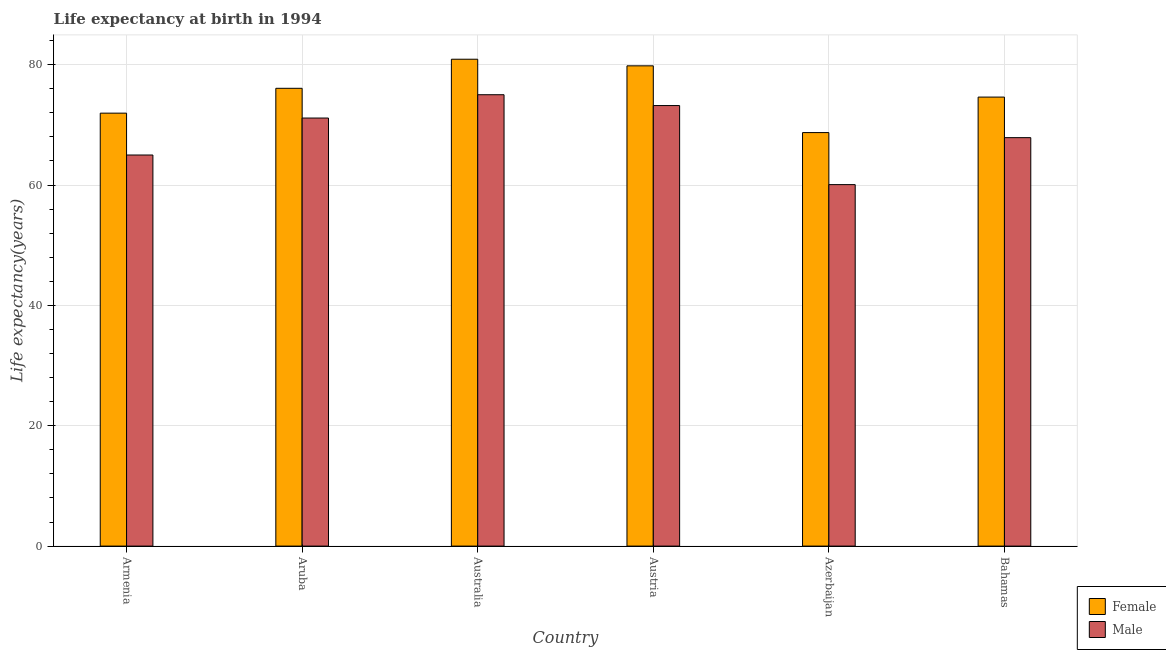How many different coloured bars are there?
Make the answer very short. 2. How many groups of bars are there?
Give a very brief answer. 6. How many bars are there on the 1st tick from the left?
Give a very brief answer. 2. How many bars are there on the 2nd tick from the right?
Offer a very short reply. 2. What is the label of the 1st group of bars from the left?
Your answer should be compact. Armenia. In how many cases, is the number of bars for a given country not equal to the number of legend labels?
Give a very brief answer. 0. What is the life expectancy(female) in Bahamas?
Offer a very short reply. 74.61. Across all countries, what is the maximum life expectancy(female)?
Your answer should be very brief. 80.9. Across all countries, what is the minimum life expectancy(female)?
Make the answer very short. 68.71. In which country was the life expectancy(female) minimum?
Provide a short and direct response. Azerbaijan. What is the total life expectancy(male) in the graph?
Make the answer very short. 412.24. What is the difference between the life expectancy(female) in Armenia and that in Australia?
Make the answer very short. -8.96. What is the difference between the life expectancy(female) in Azerbaijan and the life expectancy(male) in Armenia?
Make the answer very short. 3.73. What is the average life expectancy(male) per country?
Keep it short and to the point. 68.71. What is the difference between the life expectancy(female) and life expectancy(male) in Aruba?
Your response must be concise. 4.94. In how many countries, is the life expectancy(male) greater than 48 years?
Ensure brevity in your answer.  6. What is the ratio of the life expectancy(male) in Australia to that in Austria?
Ensure brevity in your answer.  1.02. Is the difference between the life expectancy(male) in Aruba and Austria greater than the difference between the life expectancy(female) in Aruba and Austria?
Provide a short and direct response. Yes. What is the difference between the highest and the second highest life expectancy(female)?
Your answer should be compact. 1.1. What is the difference between the highest and the lowest life expectancy(female)?
Your response must be concise. 12.19. In how many countries, is the life expectancy(male) greater than the average life expectancy(male) taken over all countries?
Ensure brevity in your answer.  3. How many bars are there?
Offer a terse response. 12. Are all the bars in the graph horizontal?
Your answer should be compact. No. How many countries are there in the graph?
Your answer should be very brief. 6. What is the difference between two consecutive major ticks on the Y-axis?
Offer a terse response. 20. Are the values on the major ticks of Y-axis written in scientific E-notation?
Give a very brief answer. No. Does the graph contain any zero values?
Provide a short and direct response. No. Does the graph contain grids?
Make the answer very short. Yes. What is the title of the graph?
Ensure brevity in your answer.  Life expectancy at birth in 1994. What is the label or title of the X-axis?
Your answer should be compact. Country. What is the label or title of the Y-axis?
Provide a succinct answer. Life expectancy(years). What is the Life expectancy(years) in Female in Armenia?
Your response must be concise. 71.94. What is the Life expectancy(years) in Male in Armenia?
Keep it short and to the point. 64.98. What is the Life expectancy(years) in Female in Aruba?
Offer a very short reply. 76.07. What is the Life expectancy(years) of Male in Aruba?
Your answer should be very brief. 71.13. What is the Life expectancy(years) of Female in Australia?
Ensure brevity in your answer.  80.9. What is the Life expectancy(years) of Female in Austria?
Offer a very short reply. 79.8. What is the Life expectancy(years) of Male in Austria?
Give a very brief answer. 73.2. What is the Life expectancy(years) in Female in Azerbaijan?
Provide a short and direct response. 68.71. What is the Life expectancy(years) in Male in Azerbaijan?
Give a very brief answer. 60.06. What is the Life expectancy(years) of Female in Bahamas?
Give a very brief answer. 74.61. What is the Life expectancy(years) in Male in Bahamas?
Ensure brevity in your answer.  67.87. Across all countries, what is the maximum Life expectancy(years) in Female?
Provide a short and direct response. 80.9. Across all countries, what is the maximum Life expectancy(years) of Male?
Provide a short and direct response. 75. Across all countries, what is the minimum Life expectancy(years) in Female?
Offer a terse response. 68.71. Across all countries, what is the minimum Life expectancy(years) of Male?
Your response must be concise. 60.06. What is the total Life expectancy(years) in Female in the graph?
Make the answer very short. 452.02. What is the total Life expectancy(years) of Male in the graph?
Keep it short and to the point. 412.24. What is the difference between the Life expectancy(years) of Female in Armenia and that in Aruba?
Provide a succinct answer. -4.13. What is the difference between the Life expectancy(years) of Male in Armenia and that in Aruba?
Offer a terse response. -6.14. What is the difference between the Life expectancy(years) of Female in Armenia and that in Australia?
Offer a terse response. -8.96. What is the difference between the Life expectancy(years) of Male in Armenia and that in Australia?
Your answer should be compact. -10.02. What is the difference between the Life expectancy(years) in Female in Armenia and that in Austria?
Provide a short and direct response. -7.86. What is the difference between the Life expectancy(years) of Male in Armenia and that in Austria?
Offer a terse response. -8.22. What is the difference between the Life expectancy(years) in Female in Armenia and that in Azerbaijan?
Your answer should be very brief. 3.23. What is the difference between the Life expectancy(years) in Male in Armenia and that in Azerbaijan?
Ensure brevity in your answer.  4.92. What is the difference between the Life expectancy(years) of Female in Armenia and that in Bahamas?
Make the answer very short. -2.67. What is the difference between the Life expectancy(years) in Male in Armenia and that in Bahamas?
Keep it short and to the point. -2.88. What is the difference between the Life expectancy(years) of Female in Aruba and that in Australia?
Give a very brief answer. -4.83. What is the difference between the Life expectancy(years) in Male in Aruba and that in Australia?
Your response must be concise. -3.87. What is the difference between the Life expectancy(years) in Female in Aruba and that in Austria?
Offer a very short reply. -3.73. What is the difference between the Life expectancy(years) of Male in Aruba and that in Austria?
Ensure brevity in your answer.  -2.07. What is the difference between the Life expectancy(years) in Female in Aruba and that in Azerbaijan?
Make the answer very short. 7.36. What is the difference between the Life expectancy(years) of Male in Aruba and that in Azerbaijan?
Keep it short and to the point. 11.06. What is the difference between the Life expectancy(years) in Female in Aruba and that in Bahamas?
Provide a short and direct response. 1.46. What is the difference between the Life expectancy(years) of Male in Aruba and that in Bahamas?
Provide a succinct answer. 3.26. What is the difference between the Life expectancy(years) of Female in Australia and that in Austria?
Provide a short and direct response. 1.1. What is the difference between the Life expectancy(years) in Male in Australia and that in Austria?
Your response must be concise. 1.8. What is the difference between the Life expectancy(years) in Female in Australia and that in Azerbaijan?
Offer a terse response. 12.19. What is the difference between the Life expectancy(years) of Male in Australia and that in Azerbaijan?
Offer a terse response. 14.94. What is the difference between the Life expectancy(years) of Female in Australia and that in Bahamas?
Give a very brief answer. 6.29. What is the difference between the Life expectancy(years) of Male in Australia and that in Bahamas?
Keep it short and to the point. 7.13. What is the difference between the Life expectancy(years) of Female in Austria and that in Azerbaijan?
Give a very brief answer. 11.09. What is the difference between the Life expectancy(years) in Male in Austria and that in Azerbaijan?
Make the answer very short. 13.13. What is the difference between the Life expectancy(years) in Female in Austria and that in Bahamas?
Offer a very short reply. 5.19. What is the difference between the Life expectancy(years) in Male in Austria and that in Bahamas?
Provide a short and direct response. 5.33. What is the difference between the Life expectancy(years) in Female in Azerbaijan and that in Bahamas?
Give a very brief answer. -5.9. What is the difference between the Life expectancy(years) in Male in Azerbaijan and that in Bahamas?
Ensure brevity in your answer.  -7.8. What is the difference between the Life expectancy(years) in Female in Armenia and the Life expectancy(years) in Male in Aruba?
Make the answer very short. 0.81. What is the difference between the Life expectancy(years) of Female in Armenia and the Life expectancy(years) of Male in Australia?
Provide a succinct answer. -3.06. What is the difference between the Life expectancy(years) in Female in Armenia and the Life expectancy(years) in Male in Austria?
Offer a terse response. -1.26. What is the difference between the Life expectancy(years) in Female in Armenia and the Life expectancy(years) in Male in Azerbaijan?
Provide a short and direct response. 11.88. What is the difference between the Life expectancy(years) in Female in Armenia and the Life expectancy(years) in Male in Bahamas?
Your answer should be very brief. 4.07. What is the difference between the Life expectancy(years) of Female in Aruba and the Life expectancy(years) of Male in Australia?
Keep it short and to the point. 1.07. What is the difference between the Life expectancy(years) in Female in Aruba and the Life expectancy(years) in Male in Austria?
Offer a terse response. 2.87. What is the difference between the Life expectancy(years) of Female in Aruba and the Life expectancy(years) of Male in Azerbaijan?
Give a very brief answer. 16. What is the difference between the Life expectancy(years) in Female in Aruba and the Life expectancy(years) in Male in Bahamas?
Your answer should be compact. 8.2. What is the difference between the Life expectancy(years) of Female in Australia and the Life expectancy(years) of Male in Azerbaijan?
Provide a succinct answer. 20.84. What is the difference between the Life expectancy(years) of Female in Australia and the Life expectancy(years) of Male in Bahamas?
Make the answer very short. 13.03. What is the difference between the Life expectancy(years) of Female in Austria and the Life expectancy(years) of Male in Azerbaijan?
Ensure brevity in your answer.  19.73. What is the difference between the Life expectancy(years) in Female in Austria and the Life expectancy(years) in Male in Bahamas?
Give a very brief answer. 11.93. What is the difference between the Life expectancy(years) of Female in Azerbaijan and the Life expectancy(years) of Male in Bahamas?
Provide a succinct answer. 0.84. What is the average Life expectancy(years) in Female per country?
Your answer should be compact. 75.34. What is the average Life expectancy(years) of Male per country?
Your answer should be very brief. 68.71. What is the difference between the Life expectancy(years) of Female and Life expectancy(years) of Male in Armenia?
Keep it short and to the point. 6.96. What is the difference between the Life expectancy(years) in Female and Life expectancy(years) in Male in Aruba?
Provide a succinct answer. 4.94. What is the difference between the Life expectancy(years) in Female and Life expectancy(years) in Male in Azerbaijan?
Your response must be concise. 8.64. What is the difference between the Life expectancy(years) of Female and Life expectancy(years) of Male in Bahamas?
Provide a succinct answer. 6.74. What is the ratio of the Life expectancy(years) in Female in Armenia to that in Aruba?
Give a very brief answer. 0.95. What is the ratio of the Life expectancy(years) in Male in Armenia to that in Aruba?
Make the answer very short. 0.91. What is the ratio of the Life expectancy(years) in Female in Armenia to that in Australia?
Your answer should be compact. 0.89. What is the ratio of the Life expectancy(years) in Male in Armenia to that in Australia?
Make the answer very short. 0.87. What is the ratio of the Life expectancy(years) of Female in Armenia to that in Austria?
Give a very brief answer. 0.9. What is the ratio of the Life expectancy(years) of Male in Armenia to that in Austria?
Offer a very short reply. 0.89. What is the ratio of the Life expectancy(years) of Female in Armenia to that in Azerbaijan?
Your response must be concise. 1.05. What is the ratio of the Life expectancy(years) in Male in Armenia to that in Azerbaijan?
Offer a very short reply. 1.08. What is the ratio of the Life expectancy(years) of Female in Armenia to that in Bahamas?
Your answer should be compact. 0.96. What is the ratio of the Life expectancy(years) in Male in Armenia to that in Bahamas?
Keep it short and to the point. 0.96. What is the ratio of the Life expectancy(years) of Female in Aruba to that in Australia?
Offer a terse response. 0.94. What is the ratio of the Life expectancy(years) of Male in Aruba to that in Australia?
Your answer should be very brief. 0.95. What is the ratio of the Life expectancy(years) of Female in Aruba to that in Austria?
Provide a succinct answer. 0.95. What is the ratio of the Life expectancy(years) of Male in Aruba to that in Austria?
Your answer should be compact. 0.97. What is the ratio of the Life expectancy(years) of Female in Aruba to that in Azerbaijan?
Your answer should be very brief. 1.11. What is the ratio of the Life expectancy(years) of Male in Aruba to that in Azerbaijan?
Provide a succinct answer. 1.18. What is the ratio of the Life expectancy(years) of Female in Aruba to that in Bahamas?
Give a very brief answer. 1.02. What is the ratio of the Life expectancy(years) of Male in Aruba to that in Bahamas?
Offer a very short reply. 1.05. What is the ratio of the Life expectancy(years) of Female in Australia to that in Austria?
Your answer should be compact. 1.01. What is the ratio of the Life expectancy(years) in Male in Australia to that in Austria?
Provide a short and direct response. 1.02. What is the ratio of the Life expectancy(years) in Female in Australia to that in Azerbaijan?
Offer a terse response. 1.18. What is the ratio of the Life expectancy(years) of Male in Australia to that in Azerbaijan?
Keep it short and to the point. 1.25. What is the ratio of the Life expectancy(years) of Female in Australia to that in Bahamas?
Your response must be concise. 1.08. What is the ratio of the Life expectancy(years) of Male in Australia to that in Bahamas?
Ensure brevity in your answer.  1.11. What is the ratio of the Life expectancy(years) of Female in Austria to that in Azerbaijan?
Ensure brevity in your answer.  1.16. What is the ratio of the Life expectancy(years) of Male in Austria to that in Azerbaijan?
Provide a succinct answer. 1.22. What is the ratio of the Life expectancy(years) in Female in Austria to that in Bahamas?
Ensure brevity in your answer.  1.07. What is the ratio of the Life expectancy(years) in Male in Austria to that in Bahamas?
Make the answer very short. 1.08. What is the ratio of the Life expectancy(years) of Female in Azerbaijan to that in Bahamas?
Make the answer very short. 0.92. What is the ratio of the Life expectancy(years) of Male in Azerbaijan to that in Bahamas?
Your answer should be very brief. 0.89. What is the difference between the highest and the lowest Life expectancy(years) in Female?
Provide a succinct answer. 12.19. What is the difference between the highest and the lowest Life expectancy(years) in Male?
Your response must be concise. 14.94. 